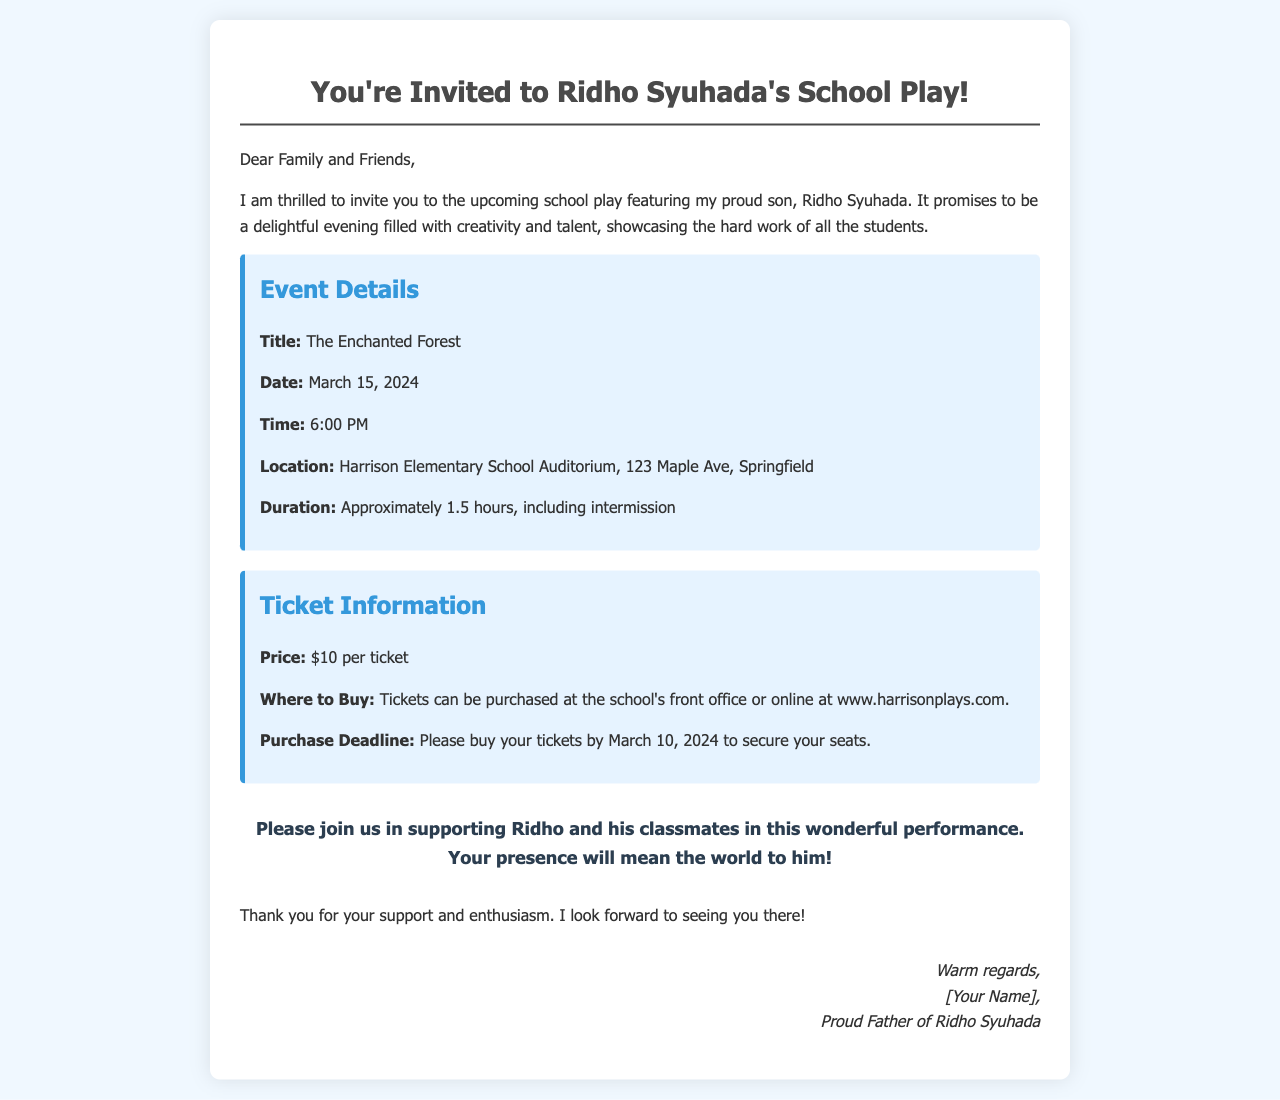What is the title of the play? The title of the play is stated in the document as "The Enchanted Forest."
Answer: The Enchanted Forest What is the date of the school play? The document specifies that the school play will take place on March 15, 2024.
Answer: March 15, 2024 What time does the school play start? The play start time is mentioned as 6:00 PM in the event details section of the document.
Answer: 6:00 PM Where can tickets be purchased? The document states that tickets can be purchased at the school's front office or online at a specific website.
Answer: School's front office or www.harrisonplays.com What is the ticket price? The document indicates that each ticket costs $10.
Answer: $10 What is the purchase deadline for tickets? The document mentions that tickets should be bought by March 10, 2024 to secure seats.
Answer: March 10, 2024 How long is the duration of the play? The document specifies that the play will last approximately 1.5 hours, including intermission.
Answer: Approximately 1.5 hours Why is the writer inviting the recipients? The writer is inviting recipients to support Ridho and his classmates in their performance.
Answer: To support Ridho and his classmates Who is the sender of the invitation? The signature at the end of the document indicates that the sender is a proud father of Ridho Syuhada.
Answer: Proud Father of Ridho Syuhada 